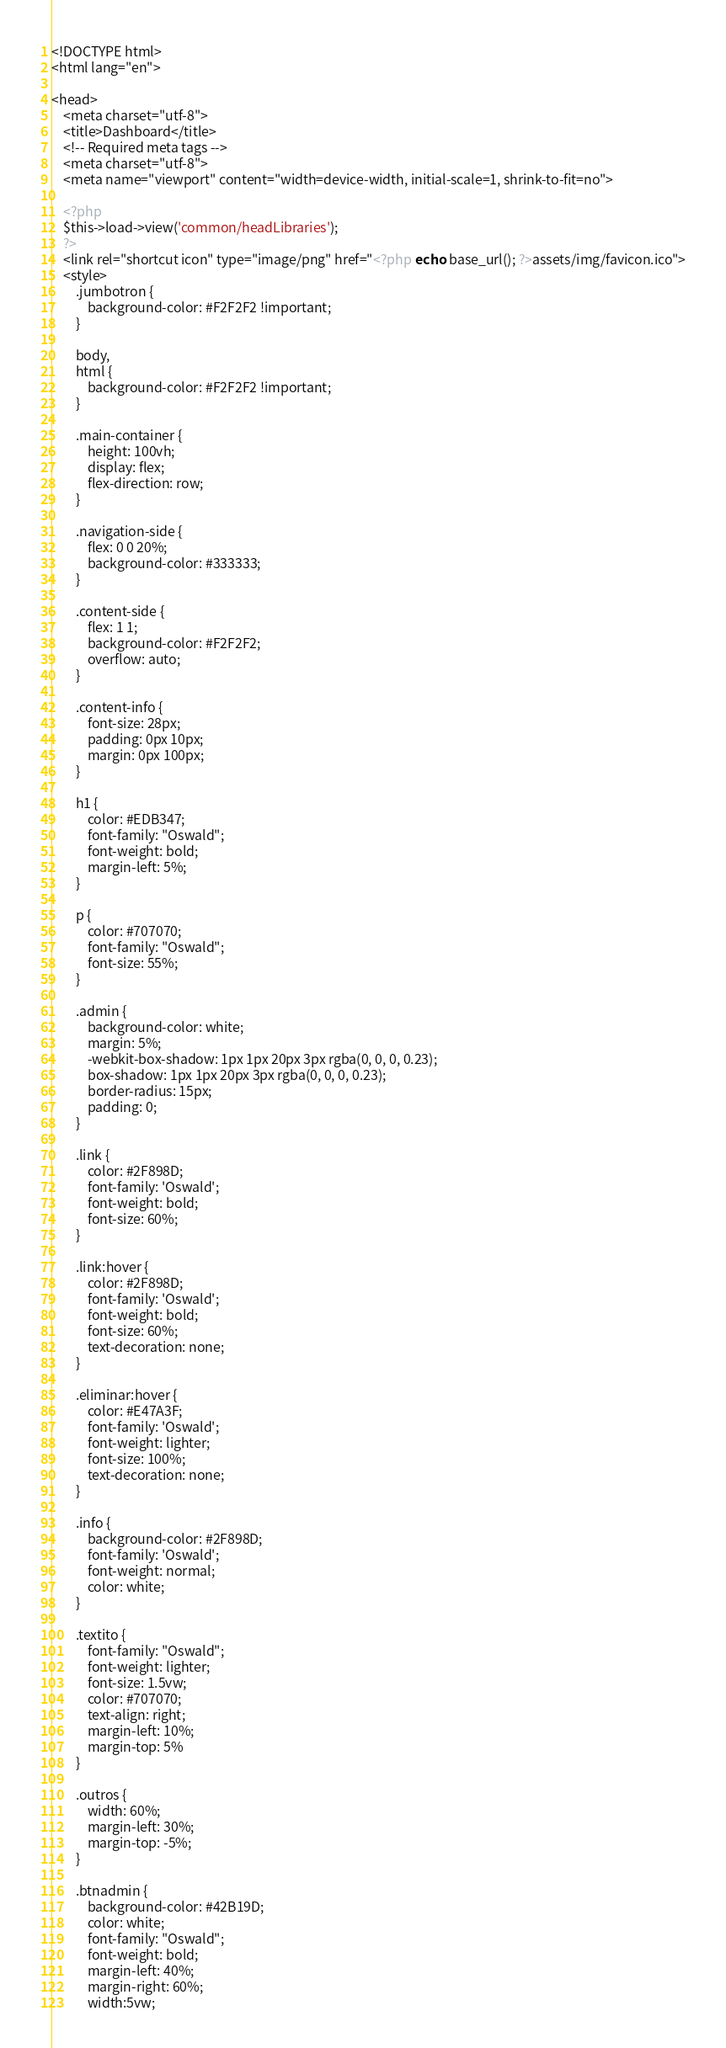Convert code to text. <code><loc_0><loc_0><loc_500><loc_500><_PHP_><!DOCTYPE html>
<html lang="en">

<head>
    <meta charset="utf-8">
    <title>Dashboard</title>
    <!-- Required meta tags -->
    <meta charset="utf-8">
    <meta name="viewport" content="width=device-width, initial-scale=1, shrink-to-fit=no">

    <?php
    $this->load->view('common/headLibraries');
    ?>
    <link rel="shortcut icon" type="image/png" href="<?php echo base_url(); ?>assets/img/favicon.ico">
    <style>
        .jumbotron {
            background-color: #F2F2F2 !important;
        }

        body,
        html {
            background-color: #F2F2F2 !important;
        }

        .main-container {
            height: 100vh;
            display: flex;
            flex-direction: row;
        }

        .navigation-side {
            flex: 0 0 20%;
            background-color: #333333;
        }

        .content-side {
            flex: 1 1;
            background-color: #F2F2F2;
            overflow: auto;
        }

        .content-info {
            font-size: 28px;
            padding: 0px 10px;
            margin: 0px 100px;
        }

        h1 {
            color: #EDB347;
            font-family: "Oswald";
            font-weight: bold;
            margin-left: 5%;
        }

        p {
            color: #707070;
            font-family: "Oswald";
            font-size: 55%;
        }

        .admin {
            background-color: white;
            margin: 5%;
            -webkit-box-shadow: 1px 1px 20px 3px rgba(0, 0, 0, 0.23);
            box-shadow: 1px 1px 20px 3px rgba(0, 0, 0, 0.23);
            border-radius: 15px;
            padding: 0;
        }

        .link {
            color: #2F898D;
            font-family: 'Oswald';
            font-weight: bold;
            font-size: 60%;
        }

        .link:hover {
            color: #2F898D;
            font-family: 'Oswald';
            font-weight: bold;
            font-size: 60%;
            text-decoration: none;
        }

        .eliminar:hover {
            color: #E47A3F;
            font-family: 'Oswald';
            font-weight: lighter;
            font-size: 100%;
            text-decoration: none;
        }

        .info {
            background-color: #2F898D;
            font-family: 'Oswald';
            font-weight: normal;
            color: white;
        }

        .textito {
            font-family: "Oswald";
            font-weight: lighter;
            font-size: 1.5vw;
            color: #707070;
            text-align: right;
            margin-left: 10%;
            margin-top: 5%
        }

        .outros {
            width: 60%;
            margin-left: 30%;
            margin-top: -5%;
        }

        .btnadmin {
            background-color: #42B19D;
            color: white;
            font-family: "Oswald";
            font-weight: bold;
            margin-left: 40%;
            margin-right: 60%;
            width:5vw;</code> 